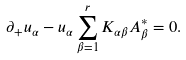Convert formula to latex. <formula><loc_0><loc_0><loc_500><loc_500>\partial _ { + } u _ { \alpha } - u _ { \alpha } \sum _ { \beta = 1 } ^ { r } K _ { \alpha \beta } A _ { \beta } ^ { * } = 0 .</formula> 